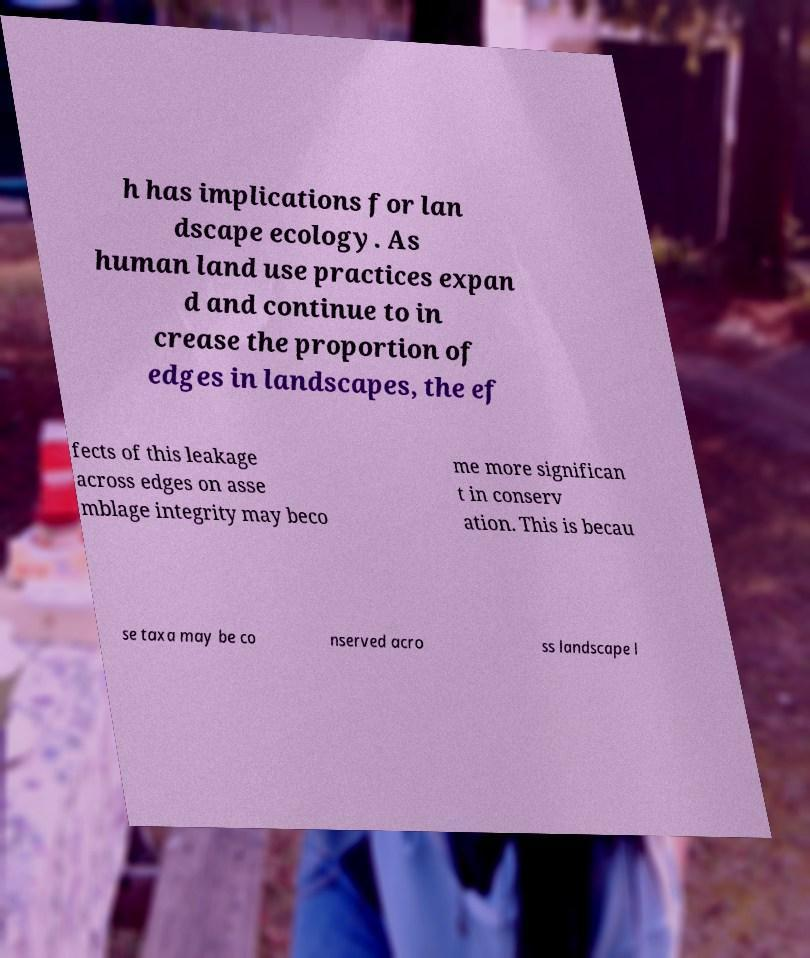Can you read and provide the text displayed in the image?This photo seems to have some interesting text. Can you extract and type it out for me? h has implications for lan dscape ecology. As human land use practices expan d and continue to in crease the proportion of edges in landscapes, the ef fects of this leakage across edges on asse mblage integrity may beco me more significan t in conserv ation. This is becau se taxa may be co nserved acro ss landscape l 